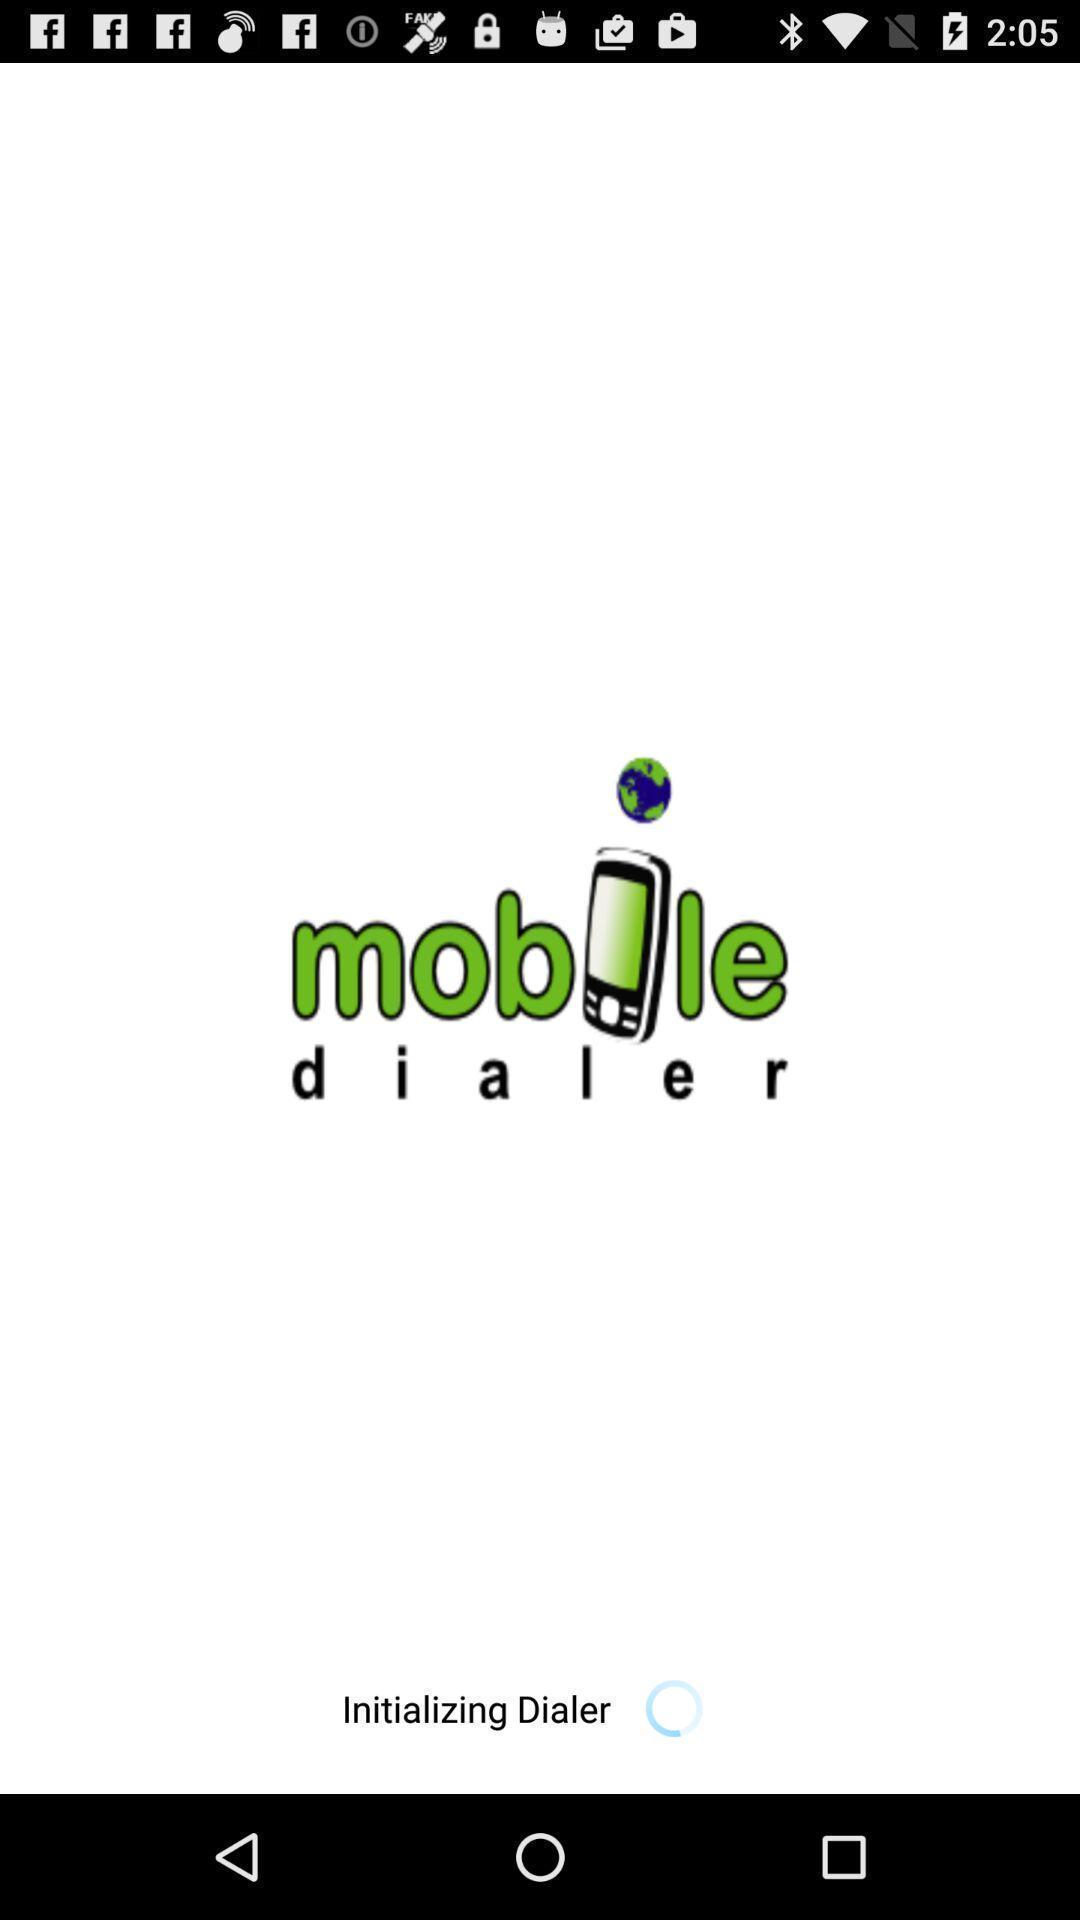What is the overall content of this screenshot? Social app for doing calling. 